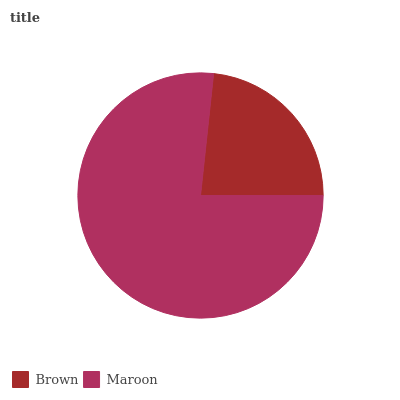Is Brown the minimum?
Answer yes or no. Yes. Is Maroon the maximum?
Answer yes or no. Yes. Is Maroon the minimum?
Answer yes or no. No. Is Maroon greater than Brown?
Answer yes or no. Yes. Is Brown less than Maroon?
Answer yes or no. Yes. Is Brown greater than Maroon?
Answer yes or no. No. Is Maroon less than Brown?
Answer yes or no. No. Is Maroon the high median?
Answer yes or no. Yes. Is Brown the low median?
Answer yes or no. Yes. Is Brown the high median?
Answer yes or no. No. Is Maroon the low median?
Answer yes or no. No. 